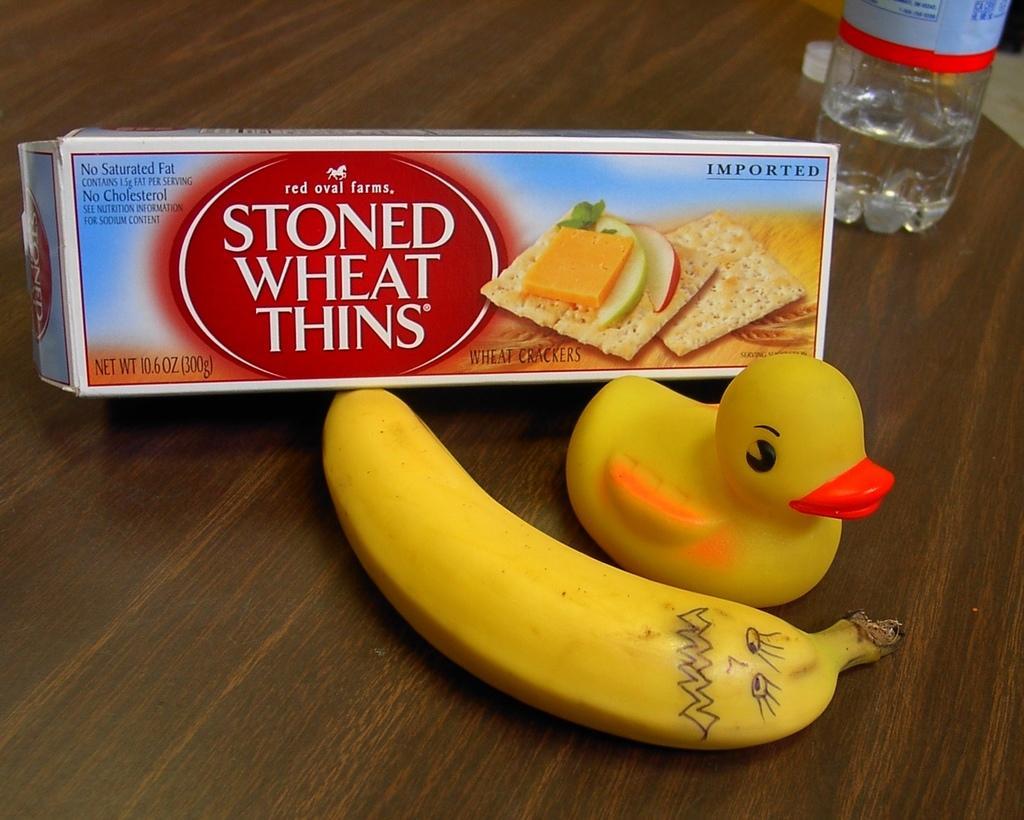In one or two sentences, can you explain what this image depicts? In the image we can see there is a banana, duck toy, cheese packet and a water bottle kept on the table. 